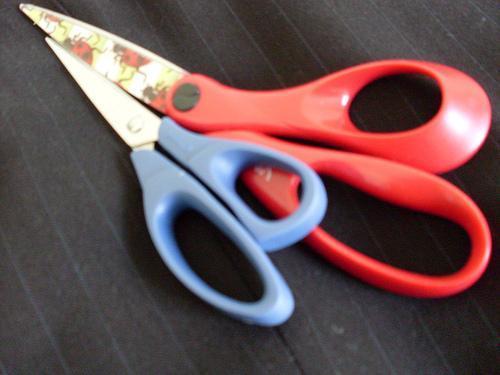How many scissors are there?
Give a very brief answer. 2. How many pairs of scissors in the picture?
Give a very brief answer. 2. How many scissors can you see?
Give a very brief answer. 2. How many kites are in the air?
Give a very brief answer. 0. 